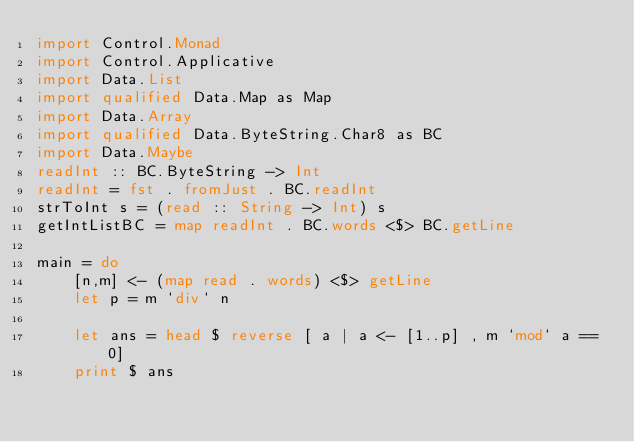Convert code to text. <code><loc_0><loc_0><loc_500><loc_500><_Haskell_>import Control.Monad
import Control.Applicative
import Data.List
import qualified Data.Map as Map
import Data.Array
import qualified Data.ByteString.Char8 as BC
import Data.Maybe
readInt :: BC.ByteString -> Int
readInt = fst . fromJust . BC.readInt
strToInt s = (read :: String -> Int) s
getIntListBC = map readInt . BC.words <$> BC.getLine

main = do
    [n,m] <- (map read . words) <$> getLine
    let p = m `div` n
    
    let ans = head $ reverse [ a | a <- [1..p] , m `mod` a == 0]
    print $ ans</code> 